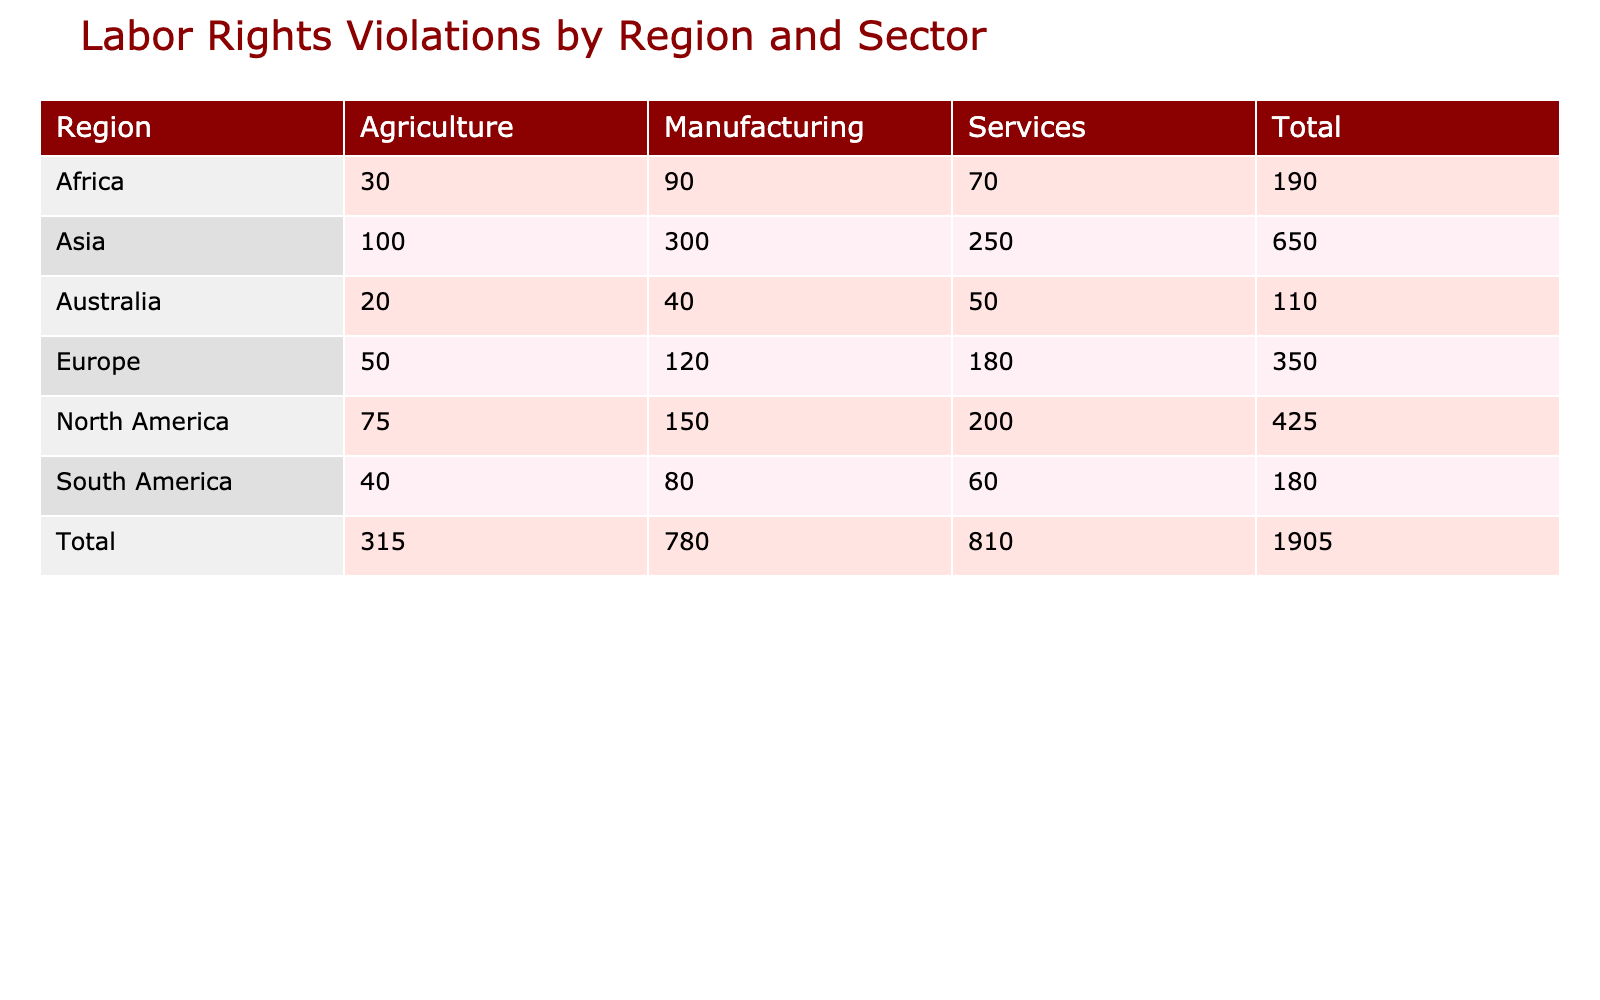What region had the highest number of reported labor rights violations in the manufacturing sector? The manufacturing violations are as follows: North America: 150, Europe: 120, Asia: 300, South America: 80, Africa: 90, Australia: 40. Asia has the highest at 300 violations.
Answer: Asia Which sector in South America reported the fewest violations? The reported violations in South America are: Manufacturing: 80, Services: 60, Agriculture: 40. Agriculture has the fewest violations at 40.
Answer: Agriculture Is the total number of reported violations in Europe greater than that in North America? The totals are North America: 150 + 200 + 75 = 425 and Europe: 120 + 180 + 50 = 350. Since 425 > 350, it is true that North America has a greater total.
Answer: Yes What is the combined total of reported violations in the agriculture sector across all regions? The agriculture violations are: North America: 75, Europe: 50, Asia: 100, South America: 40, Africa: 30, Australia: 20. The combined total is 75 + 50 + 100 + 40 + 30 + 20 = 315.
Answer: 315 In which region does the services sector have the highest reported violations? The reported violations for Services are as follows: North America: 200, Europe: 180, Asia: 250, South America: 60, Africa: 70, Australia: 50. The highest is in Asia with 250 violations.
Answer: Asia 